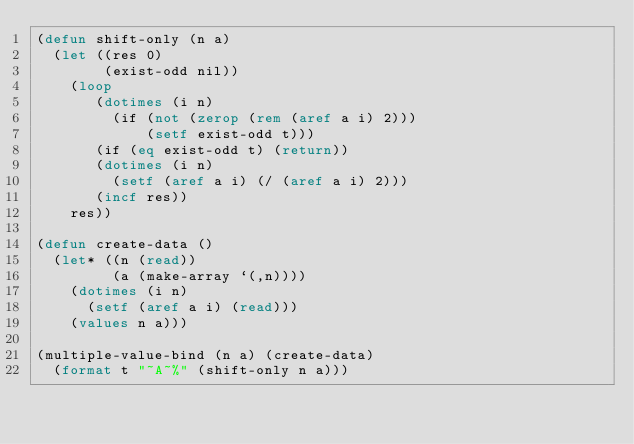Convert code to text. <code><loc_0><loc_0><loc_500><loc_500><_Lisp_>(defun shift-only (n a)
  (let ((res 0)
        (exist-odd nil))
    (loop
       (dotimes (i n)
         (if (not (zerop (rem (aref a i) 2)))
             (setf exist-odd t)))
       (if (eq exist-odd t) (return))
       (dotimes (i n)
         (setf (aref a i) (/ (aref a i) 2)))
       (incf res))
    res))

(defun create-data ()
  (let* ((n (read))
         (a (make-array `(,n))))
    (dotimes (i n)
      (setf (aref a i) (read)))
    (values n a)))

(multiple-value-bind (n a) (create-data)
  (format t "~A~%" (shift-only n a)))</code> 